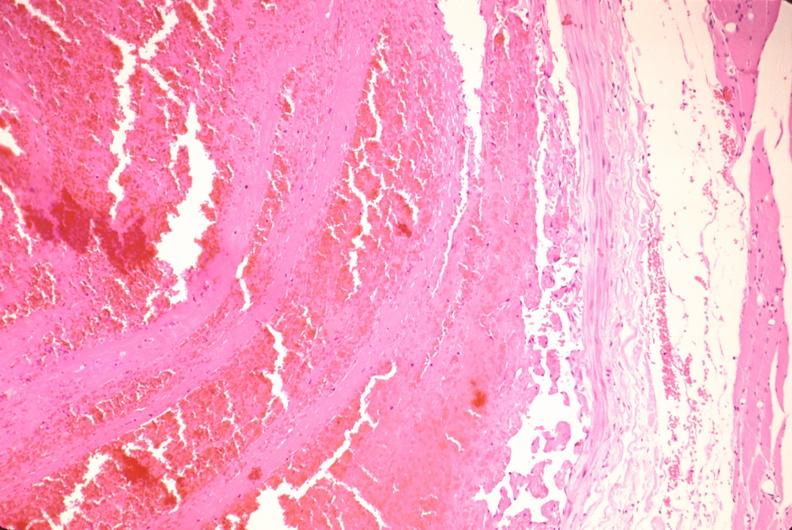what is present?
Answer the question using a single word or phrase. Vasculature 